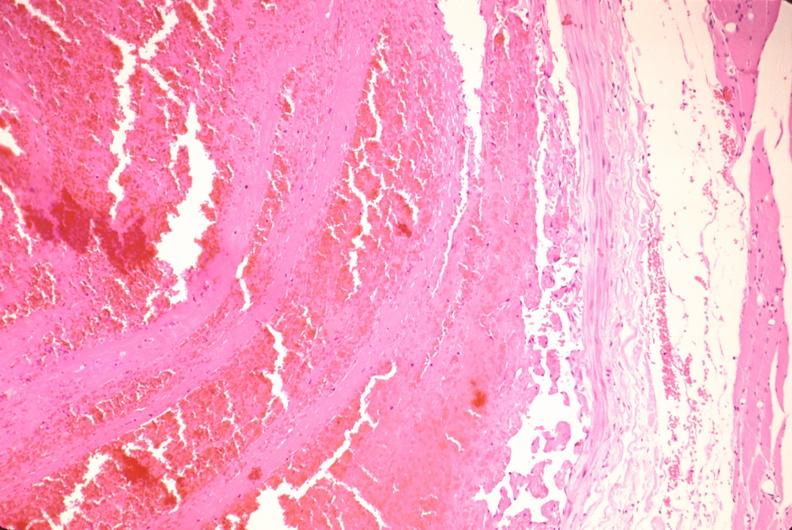what is present?
Answer the question using a single word or phrase. Vasculature 